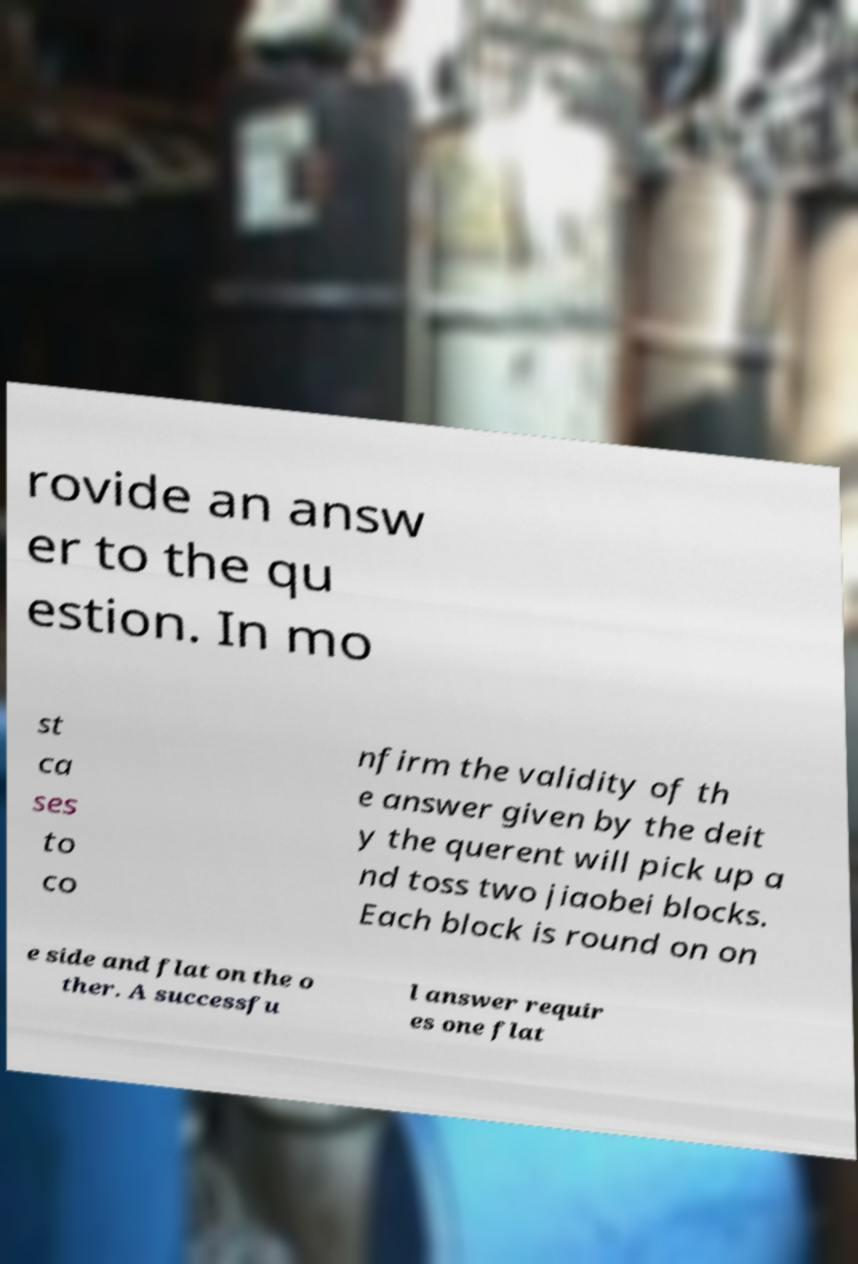For documentation purposes, I need the text within this image transcribed. Could you provide that? rovide an answ er to the qu estion. In mo st ca ses to co nfirm the validity of th e answer given by the deit y the querent will pick up a nd toss two jiaobei blocks. Each block is round on on e side and flat on the o ther. A successfu l answer requir es one flat 